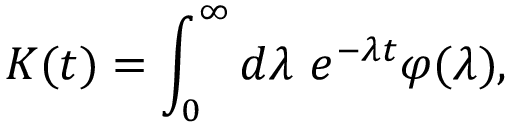Convert formula to latex. <formula><loc_0><loc_0><loc_500><loc_500>K ( t ) = \int _ { 0 } ^ { \infty } d \lambda e ^ { - \lambda t } \varphi ( \lambda ) ,</formula> 